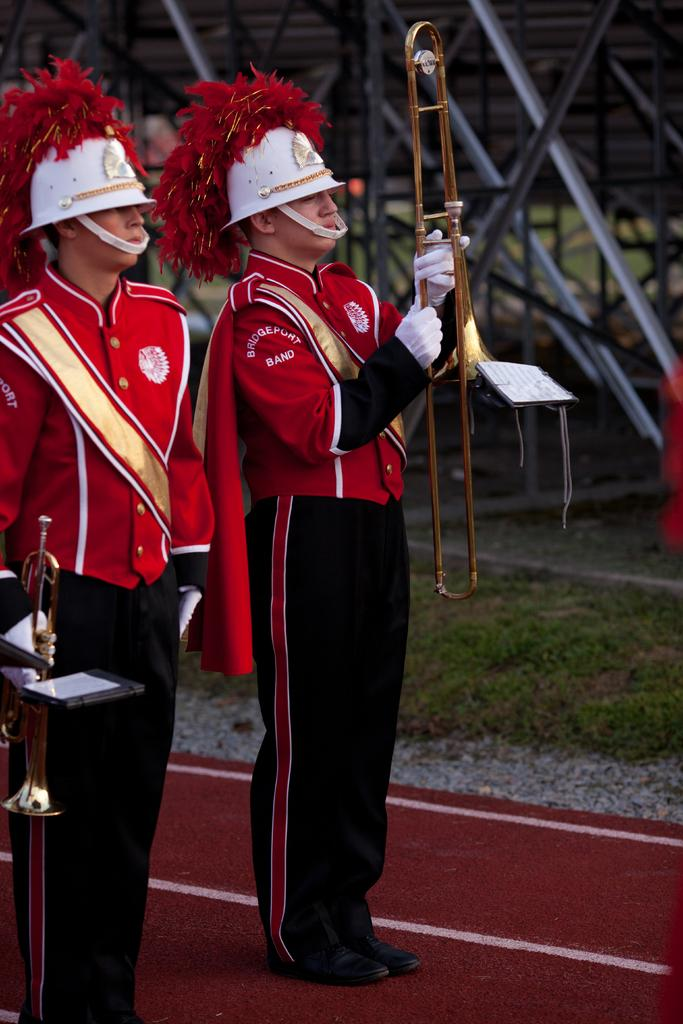<image>
Summarize the visual content of the image. Two members of the Bridgeport Band are standing on a track. 